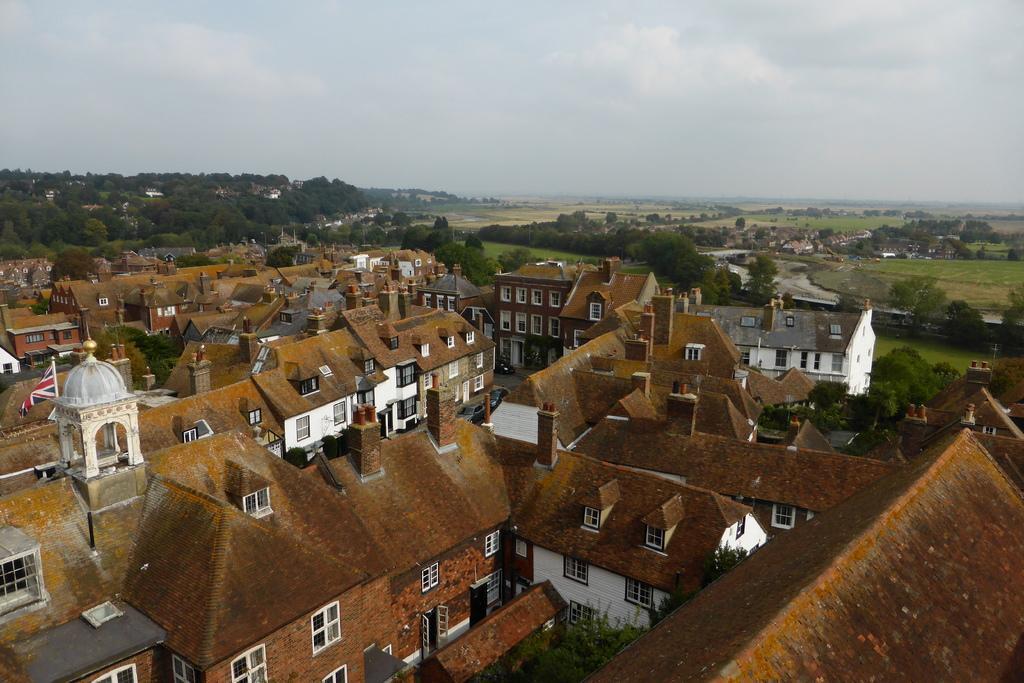In one or two sentences, can you explain what this image depicts? In this picture we can observe buildings with brown color roofs. We can observe a white color dome on the top of the building, on the left side. In the background there are trees. We can observe a sky with some clouds. 